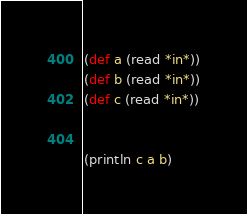Convert code to text. <code><loc_0><loc_0><loc_500><loc_500><_Clojure_>(def a (read *in*))
(def b (read *in*))
(def c (read *in*))


(println c a b)</code> 